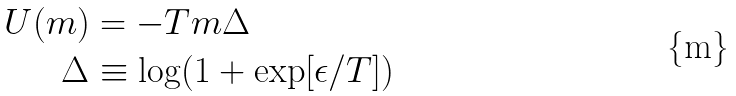Convert formula to latex. <formula><loc_0><loc_0><loc_500><loc_500>U ( m ) & = - T m \Delta \\ \Delta & \equiv \log ( 1 + \exp [ \epsilon / T ] )</formula> 